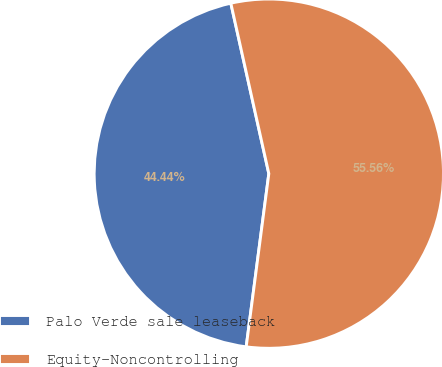<chart> <loc_0><loc_0><loc_500><loc_500><pie_chart><fcel>Palo Verde sale leaseback<fcel>Equity-Noncontrolling<nl><fcel>44.44%<fcel>55.56%<nl></chart> 